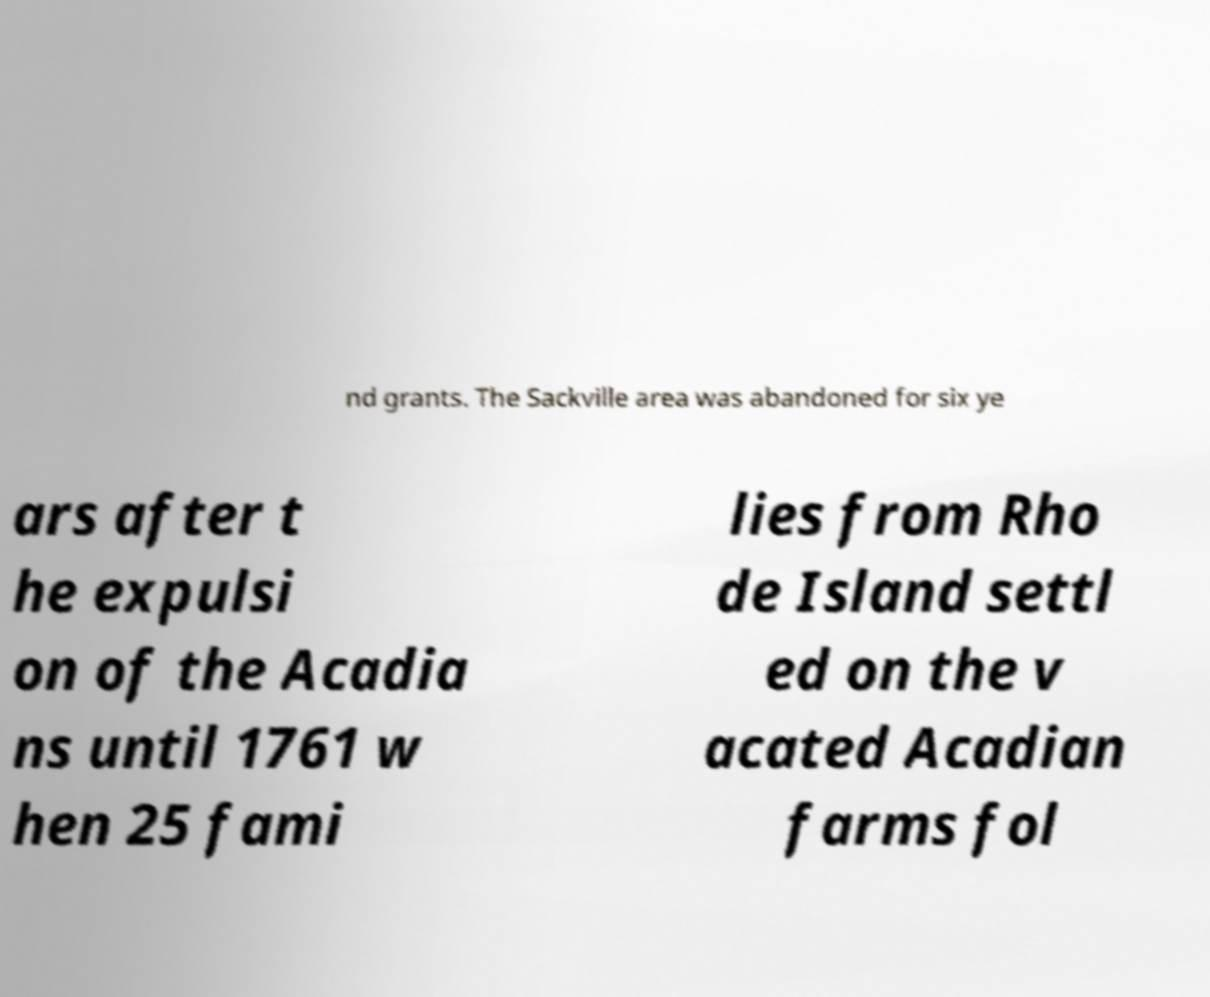Please read and relay the text visible in this image. What does it say? nd grants. The Sackville area was abandoned for six ye ars after t he expulsi on of the Acadia ns until 1761 w hen 25 fami lies from Rho de Island settl ed on the v acated Acadian farms fol 